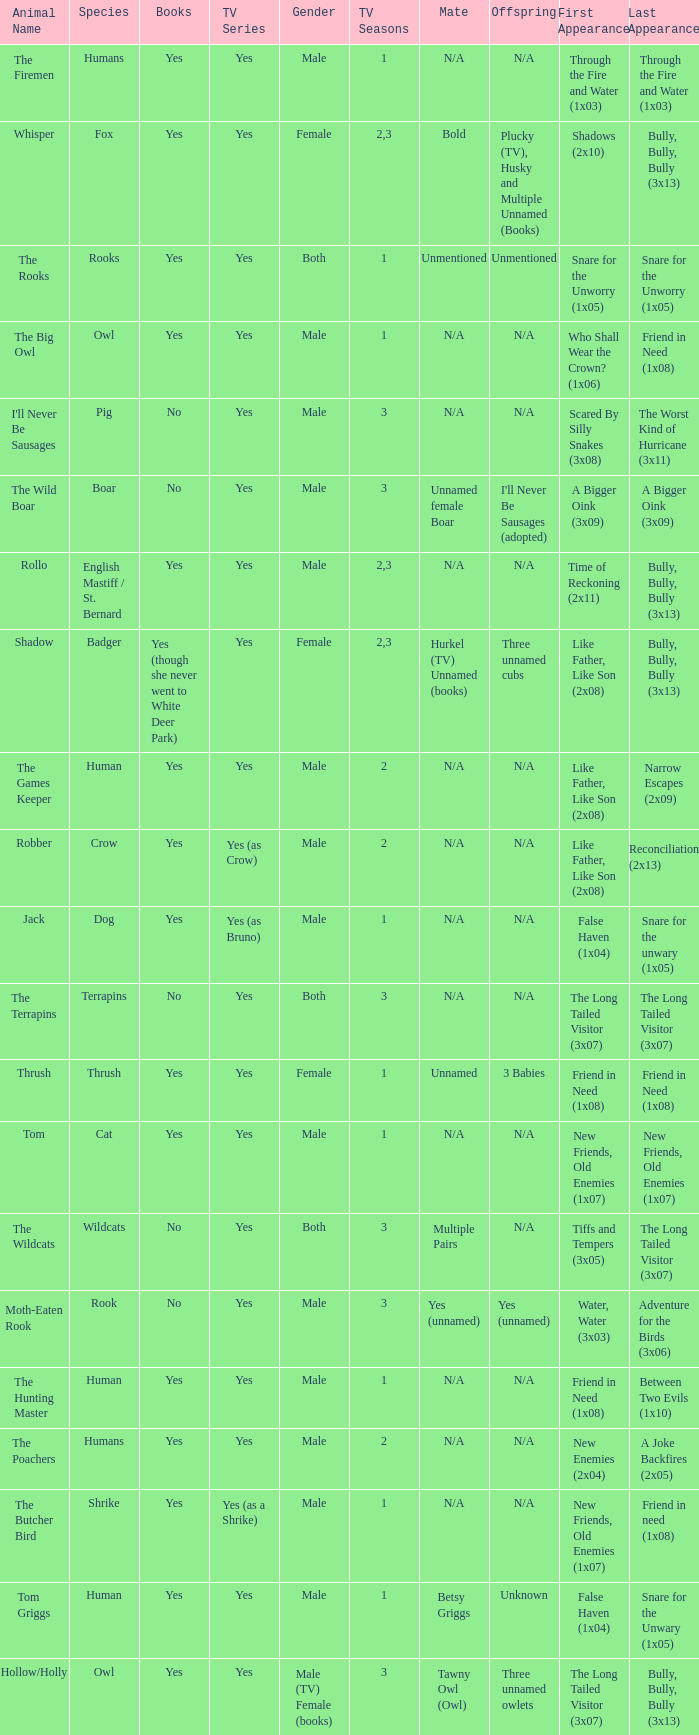What is the mate for Last Appearance of bully, bully, bully (3x13) for the animal named hollow/holly later than season 1? Tawny Owl (Owl). 